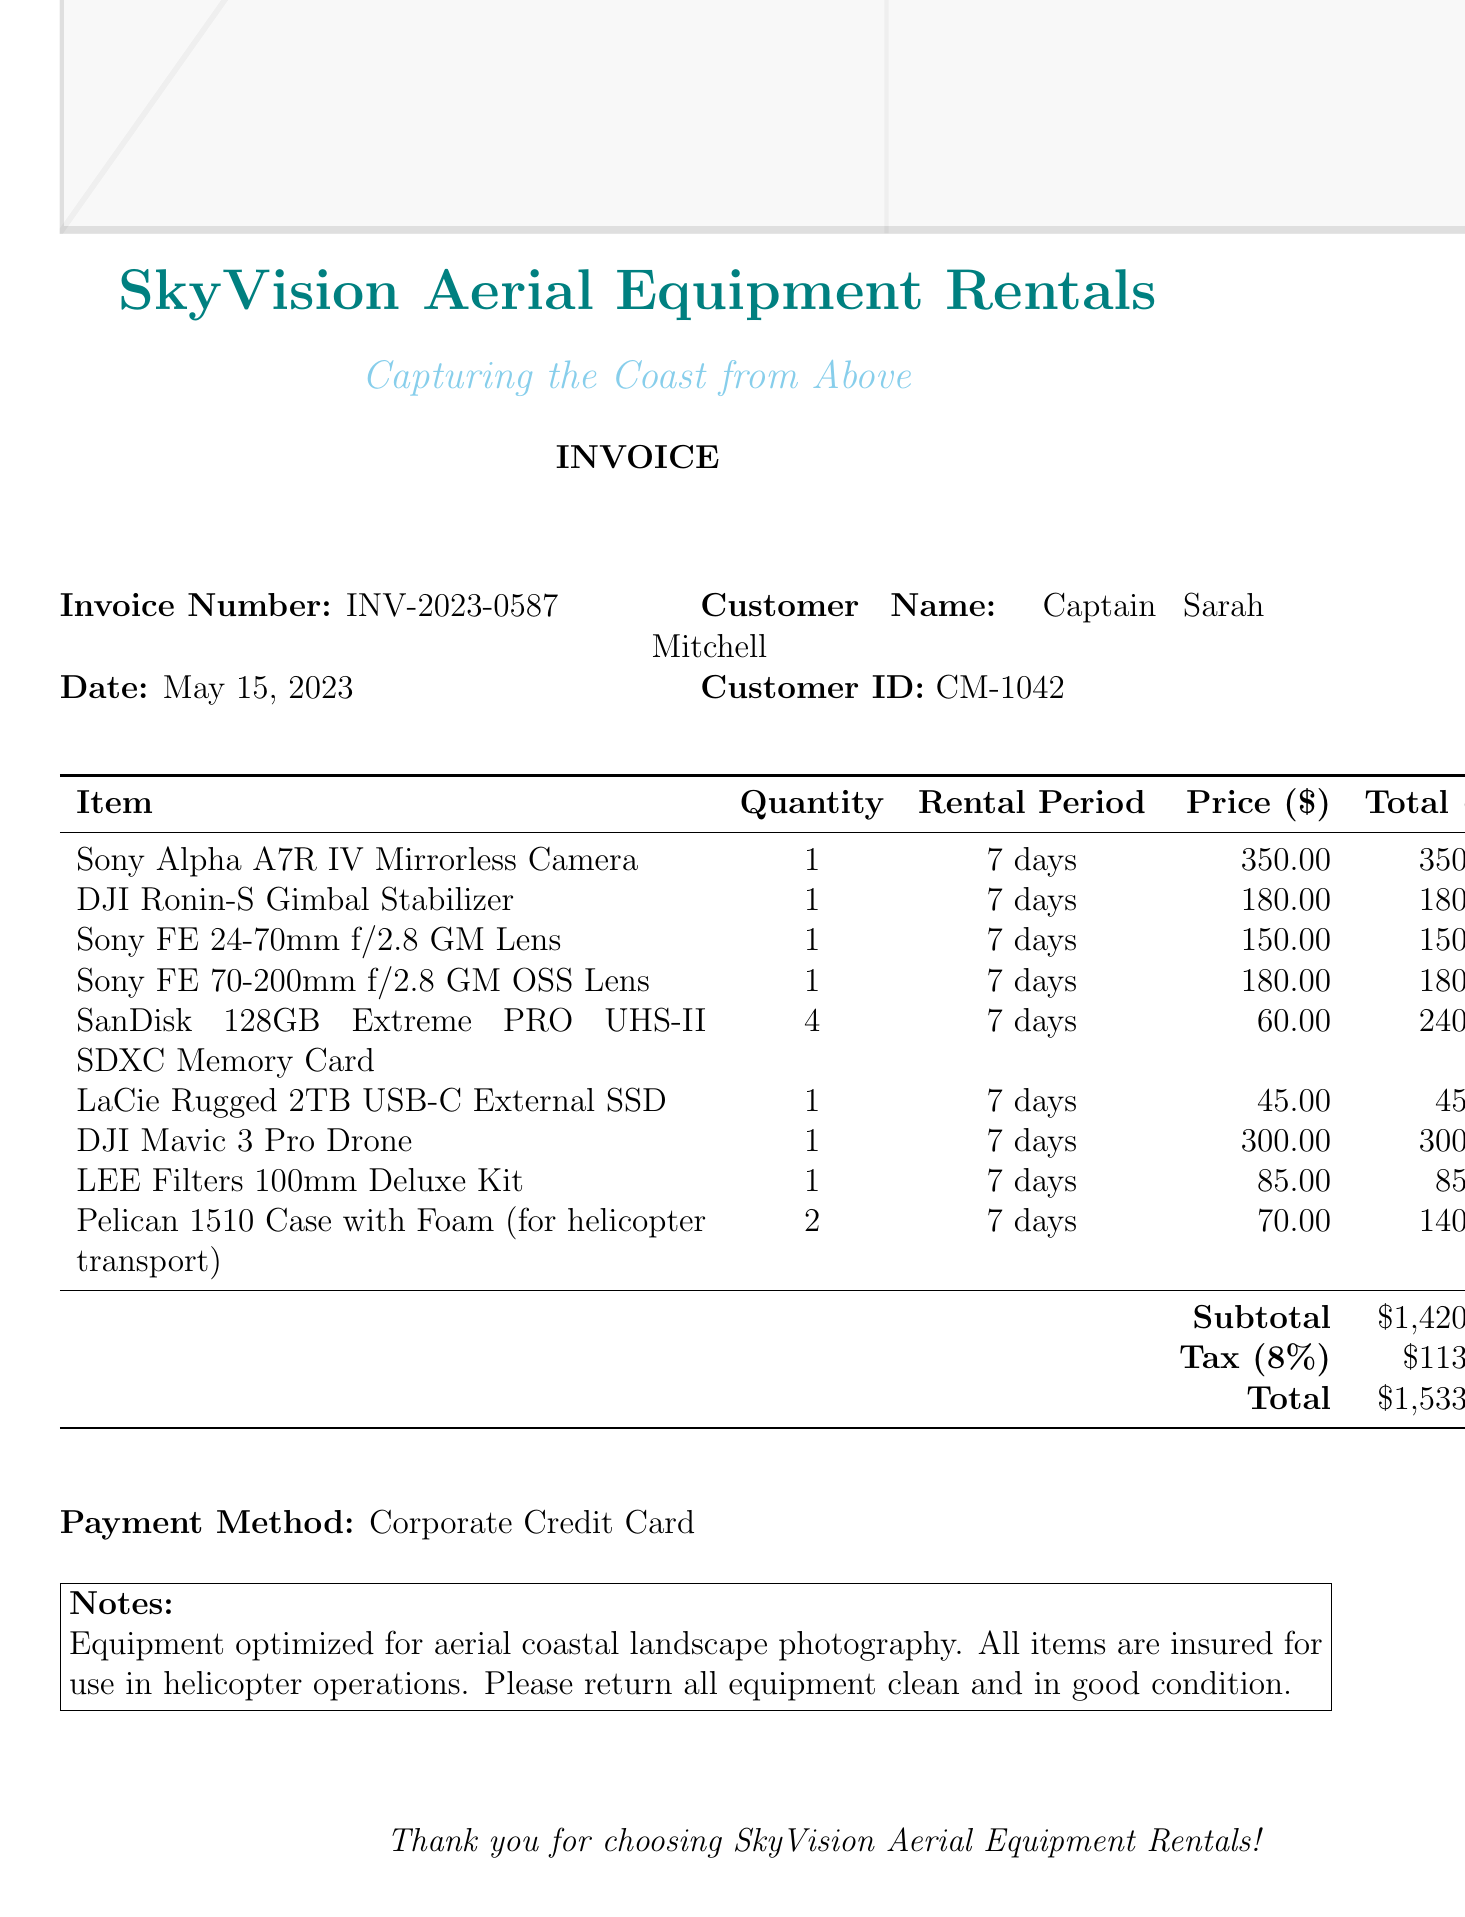What is the company name? The company name is stated at the top of the document in bold.
Answer: SkyVision Aerial Equipment Rentals What is the invoice number? The invoice number is listed near the top of the document under the invoice information section.
Answer: INV-2023-0587 What is the total amount due? The total amount due is positioned at the bottom of the invoice under the total calculation section.
Answer: $1,533.60 What is the rental period for the items? The rental period is consistently specified for all items listed in the table of the invoice.
Answer: 7 days How many SanDisk memory cards were rented? The quantity of SanDisk memory cards is provided in the itemized list of rentals.
Answer: 4 What is the subtotal amount before tax? The subtotal amount is clearly indicated before the tax calculation in the total section.
Answer: $1,420.00 What payment method was used? The payment method is mentioned towards the end of the document.
Answer: Corporate Credit Card Are the items insured for helicopter operations? The notes section clearly states the insurance details for the rented items.
Answer: Yes Which lens is included in the rental items? The rental items list multiple lenses, and one specific lens is named in that section.
Answer: Sony FE 24-70mm f/2.8 GM Lens 